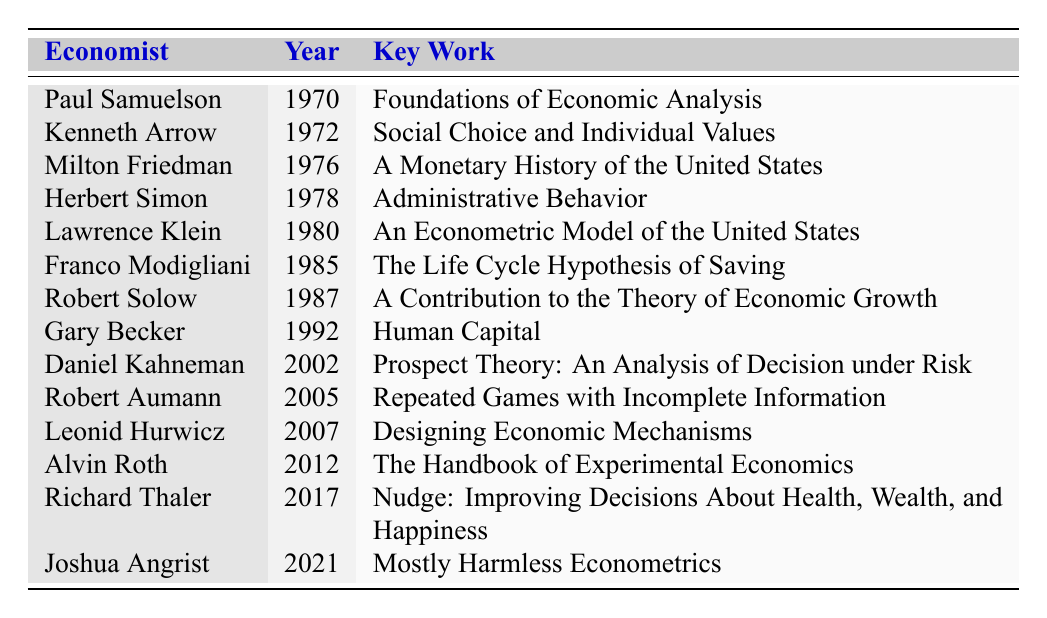What year did Paul Samuelson win the Nobel Prize? The table lists Paul Samuelson in the first row under the "Year" column, indicating he won the Nobel Prize in 1970.
Answer: 1970 What is the key work of Milton Friedman? By examining the row corresponding to Milton Friedman, the "Key Work" column reveals that his key work is "A Monetary History of the United States."
Answer: A Monetary History of the United States How many economists won the Nobel Prize before the year 2000? The table lists a total of 14 economists. Examining the years, the last one before 2000 is Daniel Kahneman who won in 2002. Counting all years from 1970 to 2002, there are 9 economists before 2000.
Answer: 9 Which economist awarded the Nobel Prize in 2005? The table shows Robert Aumann as the economist who won the Nobel Prize in 2005.
Answer: Robert Aumann What is the key work for the economist who won the Nobel Prize in 2012? Referring to the row for 2012, the table indicates that Alvin Roth's key work is "The Handbook of Experimental Economics."
Answer: The Handbook of Experimental Economics Who is the earliest economist listed in the table? Paul Samuelson is the first entry in the table with a Nobel Prize year of 1970, making him the earliest.
Answer: Paul Samuelson How many Nobel Prize-winning economists have key works related to human behavior? The economists with key works related to human behavior include Daniel Kahneman and Richard Thaler. Counting these entries, there are 2 economists.
Answer: 2 What is the average year of the awarded Nobel Prize for these economists? Calculating the average, we sum the years (1970 + 1972 + ... + 2021) = 2005 and divide by the number of economists (14): 2005/14 ≈ 143.21, so the result rounds to 2005/14 ≈ 2005.
Answer: 2005 Who wrote "Designing Economic Mechanisms"? The table specifies that Leonid Hurwicz is the author of "Designing Economic Mechanisms," which corresponds to 2007.
Answer: Leonid Hurwicz Is it true that Gary Becker won the Nobel Prize after Franco Modigliani? By looking at the years, Gary Becker (1992) won after Franco Modigliani (1985). Thus, the statement is true.
Answer: Yes Which Nobel Prize-winning economist has the key work related to human capital? The entry for Gary Becker indicates that his key work is "Human Capital," making him the economist associated with that topic.
Answer: Gary Becker 